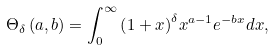Convert formula to latex. <formula><loc_0><loc_0><loc_500><loc_500>{ \Theta _ { \delta } } \left ( { a , b } \right ) = \int _ { 0 } ^ { \infty } { { { \left ( { 1 + x } \right ) } ^ { \delta } } { x ^ { a - 1 } } { e ^ { - b x } } d x } ,</formula> 